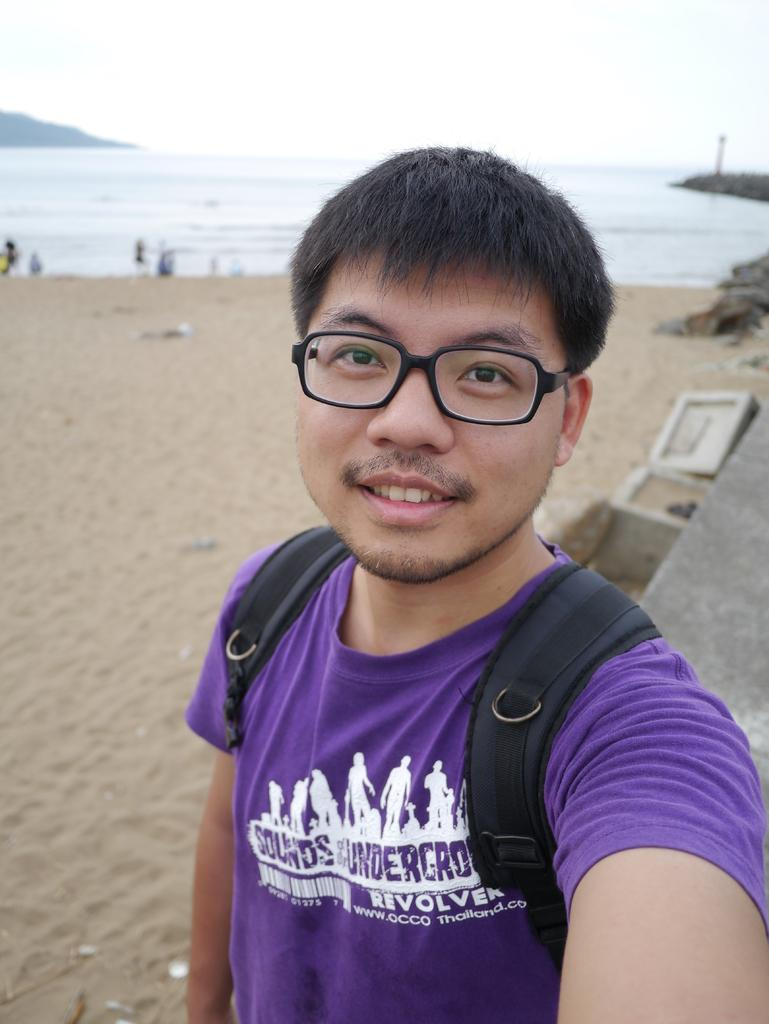What is the man in the image wearing on his back? The man is wearing a backpack. What type of eyewear is the man wearing in the image? The man is wearing spectacles. What can be seen in the background of the image? There is water visible in the image, and the sky appears to be cloudy. How many people are present in the image? The number of people is not specified, but there are people standing in the image. What type of pancake is being flipped in the image? There is no pancake present in the image; it features a man standing with a backpack and spectacles, water in the background, and a cloudy sky. What type of beast can be seen roaming in the image? There is no beast present in the image; it features a man standing with a backpack and spectacles, water in the background, and a cloudy sky. 